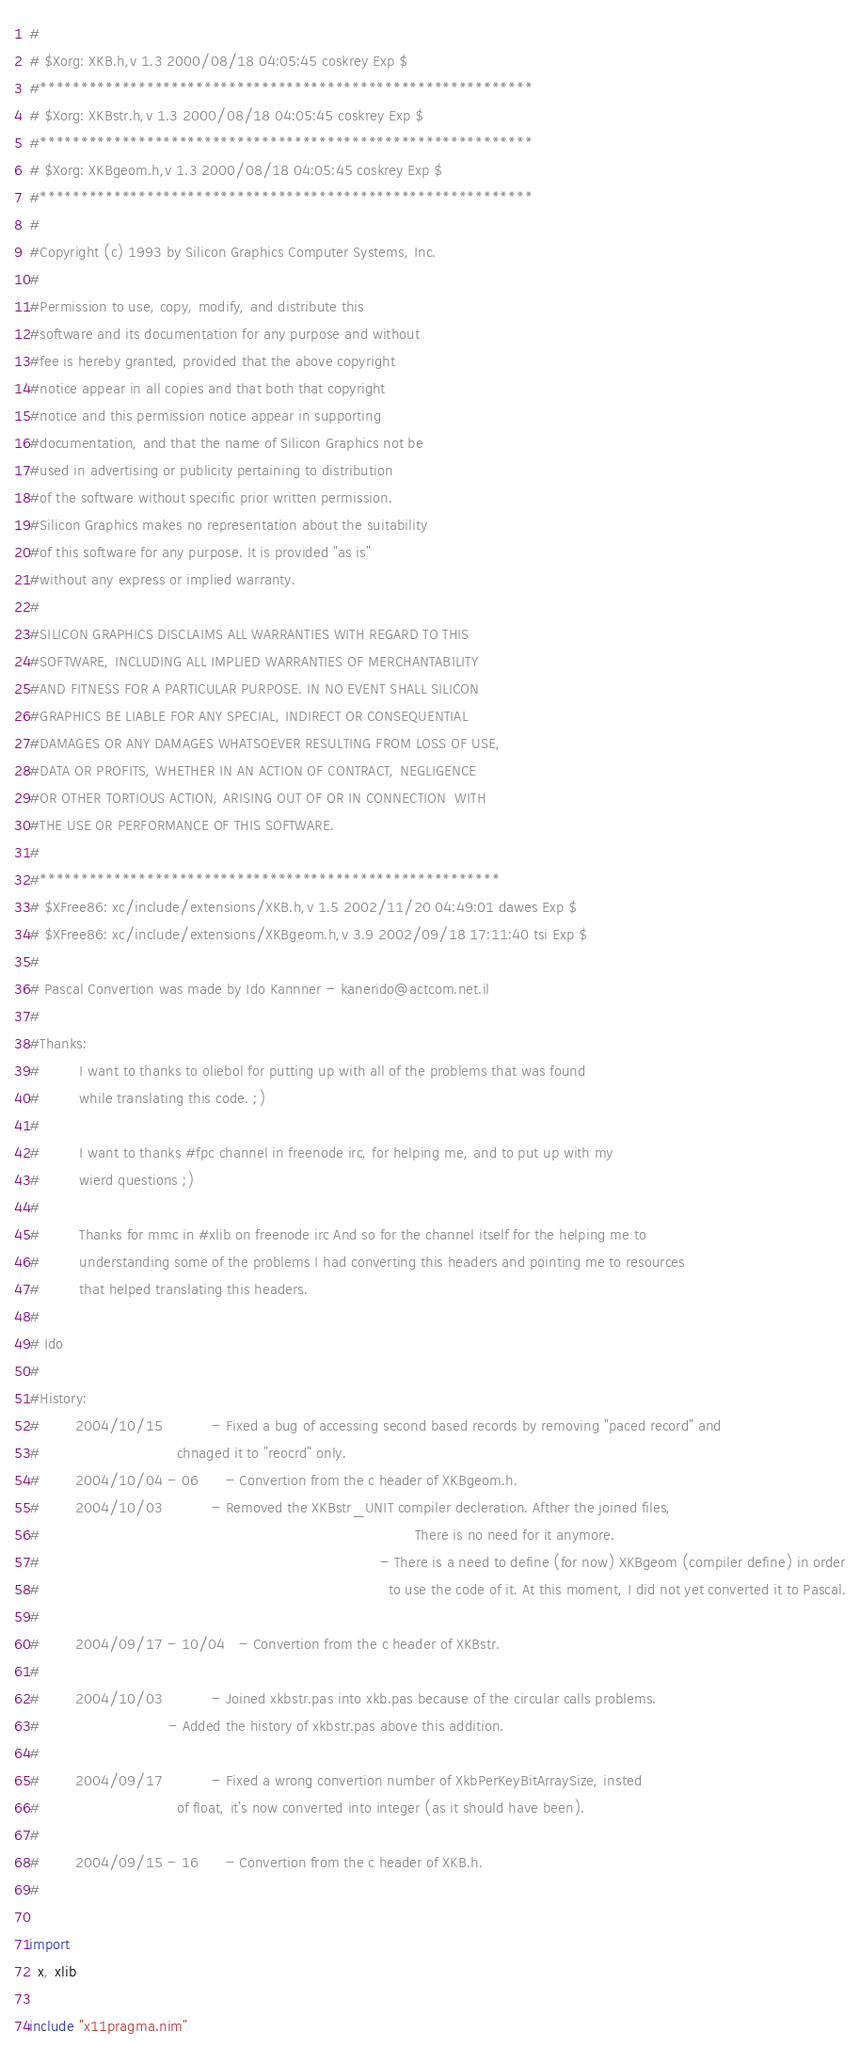<code> <loc_0><loc_0><loc_500><loc_500><_Nim_>#
# $Xorg: XKB.h,v 1.3 2000/08/18 04:05:45 coskrey Exp $
#************************************************************
# $Xorg: XKBstr.h,v 1.3 2000/08/18 04:05:45 coskrey Exp $
#************************************************************
# $Xorg: XKBgeom.h,v 1.3 2000/08/18 04:05:45 coskrey Exp $
#************************************************************
#
#Copyright (c) 1993 by Silicon Graphics Computer Systems, Inc.
#
#Permission to use, copy, modify, and distribute this
#software and its documentation for any purpose and without
#fee is hereby granted, provided that the above copyright
#notice appear in all copies and that both that copyright
#notice and this permission notice appear in supporting
#documentation, and that the name of Silicon Graphics not be
#used in advertising or publicity pertaining to distribution
#of the software without specific prior written permission.
#Silicon Graphics makes no representation about the suitability
#of this software for any purpose. It is provided "as is"
#without any express or implied warranty.
#
#SILICON GRAPHICS DISCLAIMS ALL WARRANTIES WITH REGARD TO THIS
#SOFTWARE, INCLUDING ALL IMPLIED WARRANTIES OF MERCHANTABILITY
#AND FITNESS FOR A PARTICULAR PURPOSE. IN NO EVENT SHALL SILICON
#GRAPHICS BE LIABLE FOR ANY SPECIAL, INDIRECT OR CONSEQUENTIAL
#DAMAGES OR ANY DAMAGES WHATSOEVER RESULTING FROM LOSS OF USE,
#DATA OR PROFITS, WHETHER IN AN ACTION OF CONTRACT, NEGLIGENCE
#OR OTHER TORTIOUS ACTION, ARISING OUT OF OR IN CONNECTION  WITH
#THE USE OR PERFORMANCE OF THIS SOFTWARE.
#
#********************************************************
# $XFree86: xc/include/extensions/XKB.h,v 1.5 2002/11/20 04:49:01 dawes Exp $
# $XFree86: xc/include/extensions/XKBgeom.h,v 3.9 2002/09/18 17:11:40 tsi Exp $
#
# Pascal Convertion was made by Ido Kannner - kanerido@actcom.net.il
#
#Thanks:
#         I want to thanks to oliebol for putting up with all of the problems that was found
#         while translating this code. ;)
#
#         I want to thanks #fpc channel in freenode irc, for helping me, and to put up with my
#         wierd questions ;)
#
#         Thanks for mmc in #xlib on freenode irc And so for the channel itself for the helping me to
#         understanding some of the problems I had converting this headers and pointing me to resources
#         that helped translating this headers.
#
# Ido
#
#History:
#        2004/10/15           - Fixed a bug of accessing second based records by removing "paced record" and
#                               chnaged it to "reocrd" only.
#        2004/10/04 - 06      - Convertion from the c header of XKBgeom.h.
#        2004/10/03           - Removed the XKBstr_UNIT compiler decleration. Afther the joined files,
#                                                                                     There is no need for it anymore.
#                                                                             - There is a need to define (for now) XKBgeom (compiler define) in order
#                                                                               to use the code of it. At this moment, I did not yet converted it to Pascal.
#
#        2004/09/17 - 10/04   - Convertion from the c header of XKBstr.
#
#        2004/10/03           - Joined xkbstr.pas into xkb.pas because of the circular calls problems.
#                             - Added the history of xkbstr.pas above this addition.
#
#        2004/09/17           - Fixed a wrong convertion number of XkbPerKeyBitArraySize, insted
#                               of float, it's now converted into integer (as it should have been).
#
#        2004/09/15 - 16      - Convertion from the c header of XKB.h.
#

import
  x, xlib

include "x11pragma.nim"
</code> 